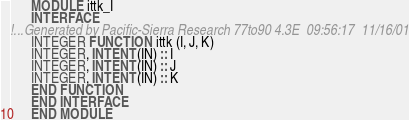<code> <loc_0><loc_0><loc_500><loc_500><_FORTRAN_>      MODULE ittk_I
      INTERFACE
!...Generated by Pacific-Sierra Research 77to90 4.3E  09:56:17  11/16/01
      INTEGER FUNCTION ittk (I, J, K)
      INTEGER, INTENT(IN) :: I
      INTEGER, INTENT(IN) :: J
      INTEGER, INTENT(IN) :: K
      END FUNCTION
      END INTERFACE
      END MODULE
</code> 